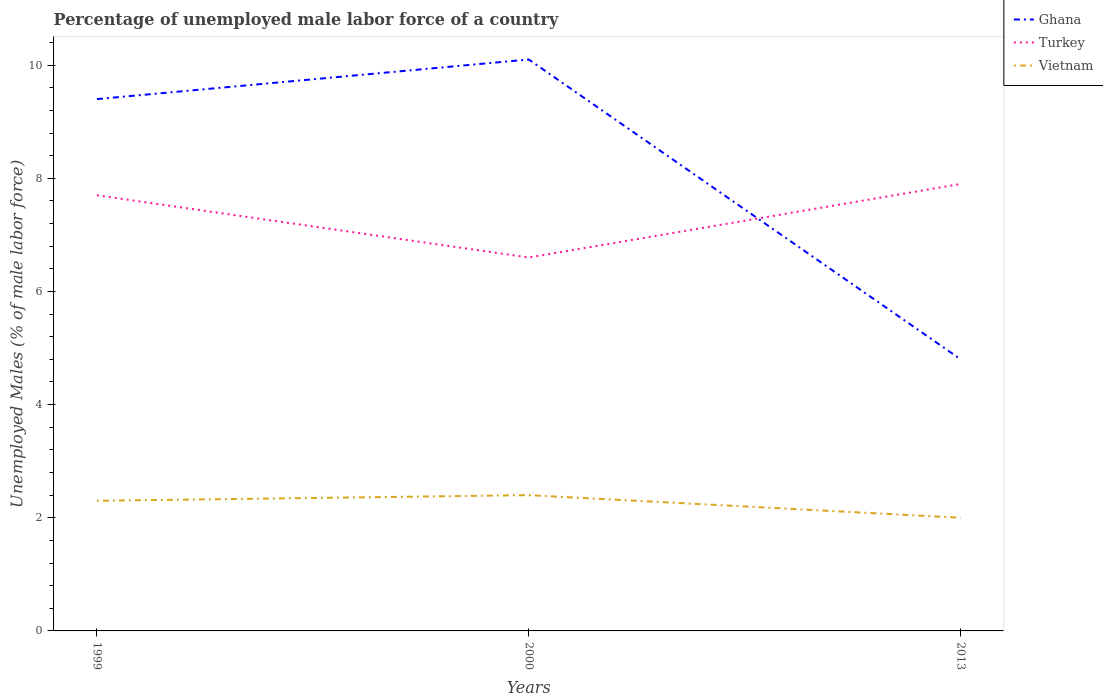Across all years, what is the maximum percentage of unemployed male labor force in Turkey?
Keep it short and to the point. 6.6. What is the total percentage of unemployed male labor force in Vietnam in the graph?
Provide a succinct answer. -0.1. What is the difference between the highest and the second highest percentage of unemployed male labor force in Vietnam?
Provide a short and direct response. 0.4. Is the percentage of unemployed male labor force in Vietnam strictly greater than the percentage of unemployed male labor force in Ghana over the years?
Your answer should be compact. Yes. How many lines are there?
Provide a succinct answer. 3. Does the graph contain grids?
Your answer should be very brief. No. Where does the legend appear in the graph?
Offer a terse response. Top right. How many legend labels are there?
Your answer should be very brief. 3. What is the title of the graph?
Keep it short and to the point. Percentage of unemployed male labor force of a country. Does "Guatemala" appear as one of the legend labels in the graph?
Provide a succinct answer. No. What is the label or title of the Y-axis?
Offer a terse response. Unemployed Males (% of male labor force). What is the Unemployed Males (% of male labor force) of Ghana in 1999?
Your answer should be compact. 9.4. What is the Unemployed Males (% of male labor force) in Turkey in 1999?
Offer a very short reply. 7.7. What is the Unemployed Males (% of male labor force) in Vietnam in 1999?
Your response must be concise. 2.3. What is the Unemployed Males (% of male labor force) in Ghana in 2000?
Provide a short and direct response. 10.1. What is the Unemployed Males (% of male labor force) of Turkey in 2000?
Provide a succinct answer. 6.6. What is the Unemployed Males (% of male labor force) of Vietnam in 2000?
Give a very brief answer. 2.4. What is the Unemployed Males (% of male labor force) of Ghana in 2013?
Keep it short and to the point. 4.8. What is the Unemployed Males (% of male labor force) of Turkey in 2013?
Offer a very short reply. 7.9. What is the Unemployed Males (% of male labor force) of Vietnam in 2013?
Give a very brief answer. 2. Across all years, what is the maximum Unemployed Males (% of male labor force) of Ghana?
Your answer should be compact. 10.1. Across all years, what is the maximum Unemployed Males (% of male labor force) in Turkey?
Offer a terse response. 7.9. Across all years, what is the maximum Unemployed Males (% of male labor force) in Vietnam?
Your answer should be compact. 2.4. Across all years, what is the minimum Unemployed Males (% of male labor force) of Ghana?
Your answer should be compact. 4.8. Across all years, what is the minimum Unemployed Males (% of male labor force) in Turkey?
Provide a succinct answer. 6.6. Across all years, what is the minimum Unemployed Males (% of male labor force) of Vietnam?
Your response must be concise. 2. What is the total Unemployed Males (% of male labor force) of Ghana in the graph?
Keep it short and to the point. 24.3. What is the difference between the Unemployed Males (% of male labor force) in Vietnam in 1999 and that in 2000?
Keep it short and to the point. -0.1. What is the difference between the Unemployed Males (% of male labor force) in Vietnam in 2000 and that in 2013?
Offer a terse response. 0.4. What is the difference between the Unemployed Males (% of male labor force) of Turkey in 1999 and the Unemployed Males (% of male labor force) of Vietnam in 2000?
Offer a terse response. 5.3. What is the difference between the Unemployed Males (% of male labor force) of Ghana in 1999 and the Unemployed Males (% of male labor force) of Turkey in 2013?
Provide a short and direct response. 1.5. What is the difference between the Unemployed Males (% of male labor force) in Ghana in 2000 and the Unemployed Males (% of male labor force) in Turkey in 2013?
Ensure brevity in your answer.  2.2. What is the average Unemployed Males (% of male labor force) in Turkey per year?
Make the answer very short. 7.4. What is the average Unemployed Males (% of male labor force) of Vietnam per year?
Provide a short and direct response. 2.23. In the year 1999, what is the difference between the Unemployed Males (% of male labor force) of Ghana and Unemployed Males (% of male labor force) of Turkey?
Ensure brevity in your answer.  1.7. In the year 1999, what is the difference between the Unemployed Males (% of male labor force) of Ghana and Unemployed Males (% of male labor force) of Vietnam?
Make the answer very short. 7.1. In the year 2000, what is the difference between the Unemployed Males (% of male labor force) of Ghana and Unemployed Males (% of male labor force) of Turkey?
Your answer should be very brief. 3.5. In the year 2000, what is the difference between the Unemployed Males (% of male labor force) of Turkey and Unemployed Males (% of male labor force) of Vietnam?
Provide a succinct answer. 4.2. In the year 2013, what is the difference between the Unemployed Males (% of male labor force) in Ghana and Unemployed Males (% of male labor force) in Turkey?
Provide a succinct answer. -3.1. What is the ratio of the Unemployed Males (% of male labor force) in Ghana in 1999 to that in 2000?
Keep it short and to the point. 0.93. What is the ratio of the Unemployed Males (% of male labor force) in Turkey in 1999 to that in 2000?
Your answer should be very brief. 1.17. What is the ratio of the Unemployed Males (% of male labor force) of Vietnam in 1999 to that in 2000?
Provide a succinct answer. 0.96. What is the ratio of the Unemployed Males (% of male labor force) in Ghana in 1999 to that in 2013?
Offer a terse response. 1.96. What is the ratio of the Unemployed Males (% of male labor force) of Turkey in 1999 to that in 2013?
Offer a very short reply. 0.97. What is the ratio of the Unemployed Males (% of male labor force) in Vietnam in 1999 to that in 2013?
Keep it short and to the point. 1.15. What is the ratio of the Unemployed Males (% of male labor force) in Ghana in 2000 to that in 2013?
Your answer should be very brief. 2.1. What is the ratio of the Unemployed Males (% of male labor force) in Turkey in 2000 to that in 2013?
Offer a very short reply. 0.84. What is the ratio of the Unemployed Males (% of male labor force) of Vietnam in 2000 to that in 2013?
Offer a very short reply. 1.2. What is the difference between the highest and the second highest Unemployed Males (% of male labor force) in Turkey?
Your answer should be very brief. 0.2. What is the difference between the highest and the lowest Unemployed Males (% of male labor force) in Ghana?
Your response must be concise. 5.3. What is the difference between the highest and the lowest Unemployed Males (% of male labor force) of Vietnam?
Offer a very short reply. 0.4. 